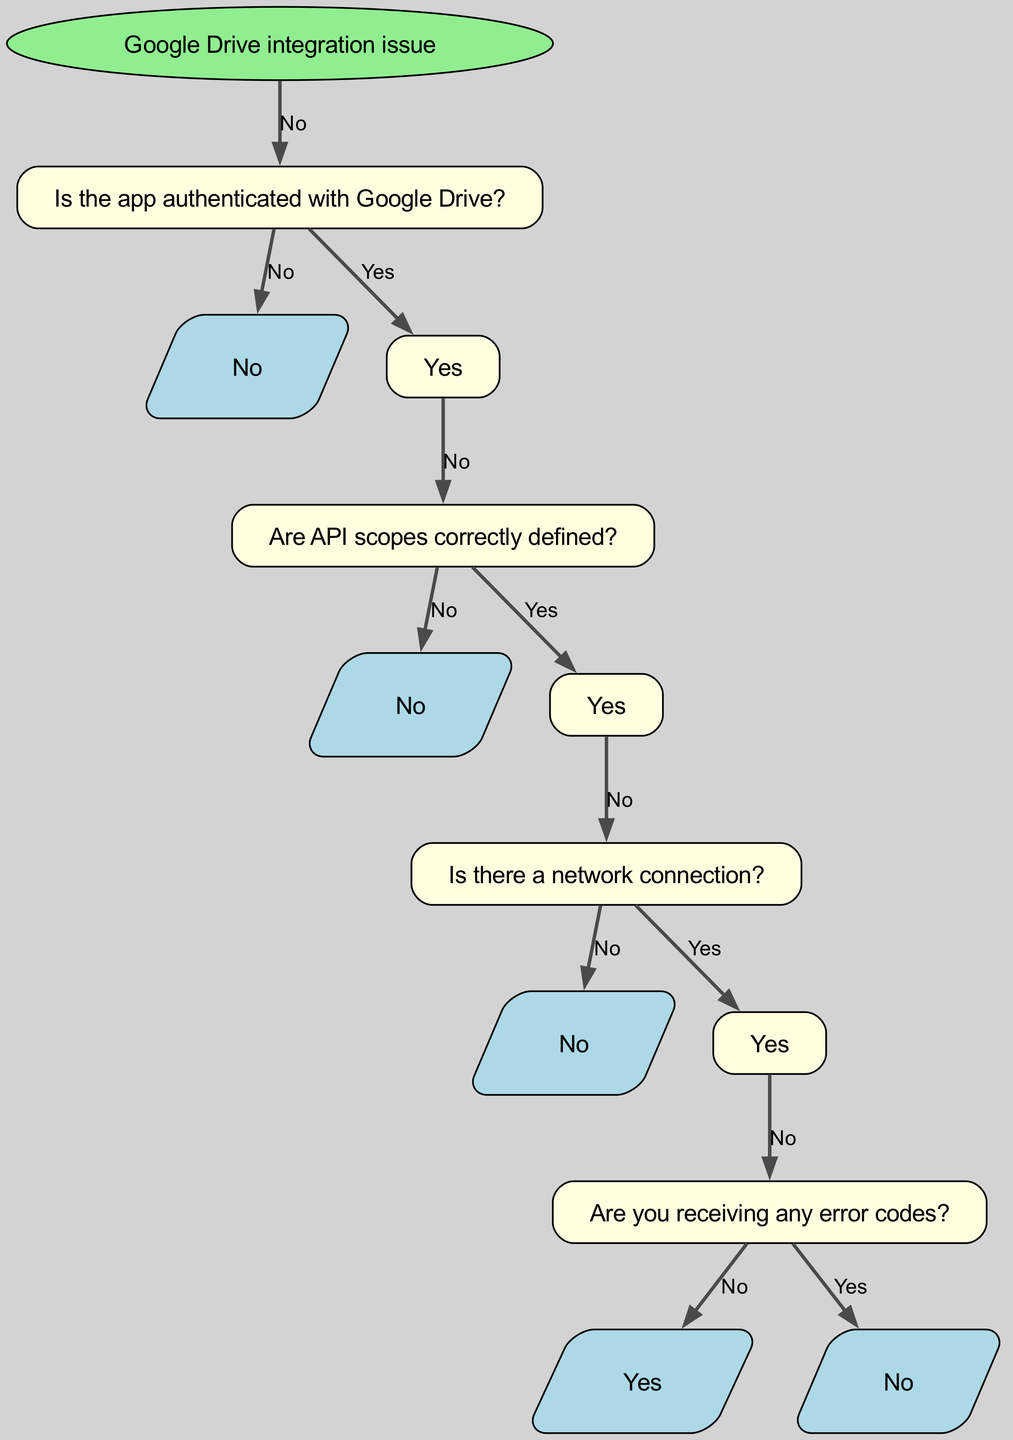What is the first node in the decision tree? The first node, or root node, in this decision tree is labeled "Google Drive integration issue". It serves as the starting point of the troubleshooting process.
Answer: Google Drive integration issue How many child nodes does the root have? The root node has one child node, which addresses whether the app is authenticated with Google Drive. The only available option is "Is the app authenticated with Google Drive?".
Answer: 1 What action should be taken if the app is not authenticated? According to the diagram, if the app is not authenticated, the action to be taken is to "Implement Google Sign-In". This is directly connected to the corresponding child node.
Answer: Implement Google Sign-In What should you check if API scopes are incorrectly defined? If API scopes are incorrectly defined, the next step indicated in the diagram is to "Update scopes in Google Developer Console". This follows the flow after confirming the app is authenticated.
Answer: Update scopes in Google Developer Console What does the diagram indicate to do if there is no network connection? The diagram specifies that if there is no network connection, you should "Check device's internet connection". This is a crucial step for resolving connectivity issues.
Answer: Check device's internet connection How many paths can be taken from the "Are API scopes correctly defined?" node? From "Are API scopes correctly defined?", there are two paths: one for "Yes" leading to check for network connection, and one for "No" leading to update the scopes, indicating that there are two distinct actions based on the API scope validation.
Answer: 2 What is the next step if there are error codes received? If error codes are received, the next step is to "Check Google Drive API documentation for error handling", which directly follows the verification of error codes.
Answer: Check Google Drive API documentation for error handling What should you do if you're not receiving any error codes? If no error codes are received, the action is to "Review app logs for issues". This step is important for diagnosing potential problems without explicit error messages.
Answer: Review app logs for issues What type of nodes follows the first decision point? The nodes following the first decision point are "Are API scopes correctly defined?" and it leads to further checks depending on whether the app is authenticated or not. This is indicative of the decision-making process outlined in the diagram.
Answer: Are API scopes correctly defined? 